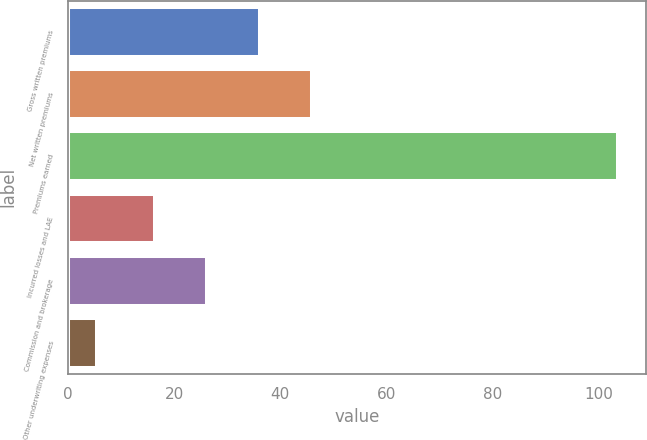<chart> <loc_0><loc_0><loc_500><loc_500><bar_chart><fcel>Gross written premiums<fcel>Net written premiums<fcel>Premiums earned<fcel>Incurred losses and LAE<fcel>Commission and brokerage<fcel>Other underwriting expenses<nl><fcel>36.1<fcel>45.92<fcel>103.7<fcel>16.3<fcel>26.12<fcel>5.5<nl></chart> 